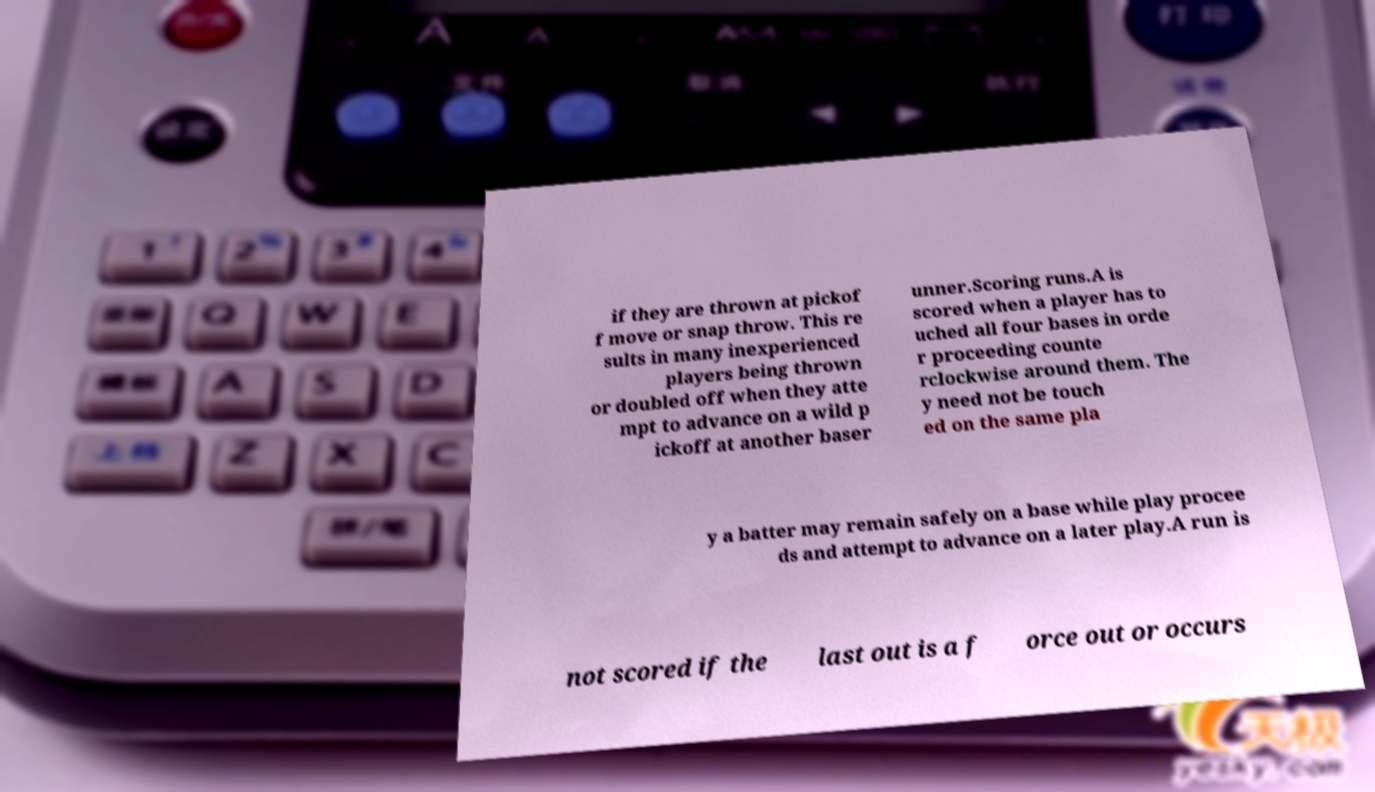Could you extract and type out the text from this image? if they are thrown at pickof f move or snap throw. This re sults in many inexperienced players being thrown or doubled off when they atte mpt to advance on a wild p ickoff at another baser unner.Scoring runs.A is scored when a player has to uched all four bases in orde r proceeding counte rclockwise around them. The y need not be touch ed on the same pla y a batter may remain safely on a base while play procee ds and attempt to advance on a later play.A run is not scored if the last out is a f orce out or occurs 